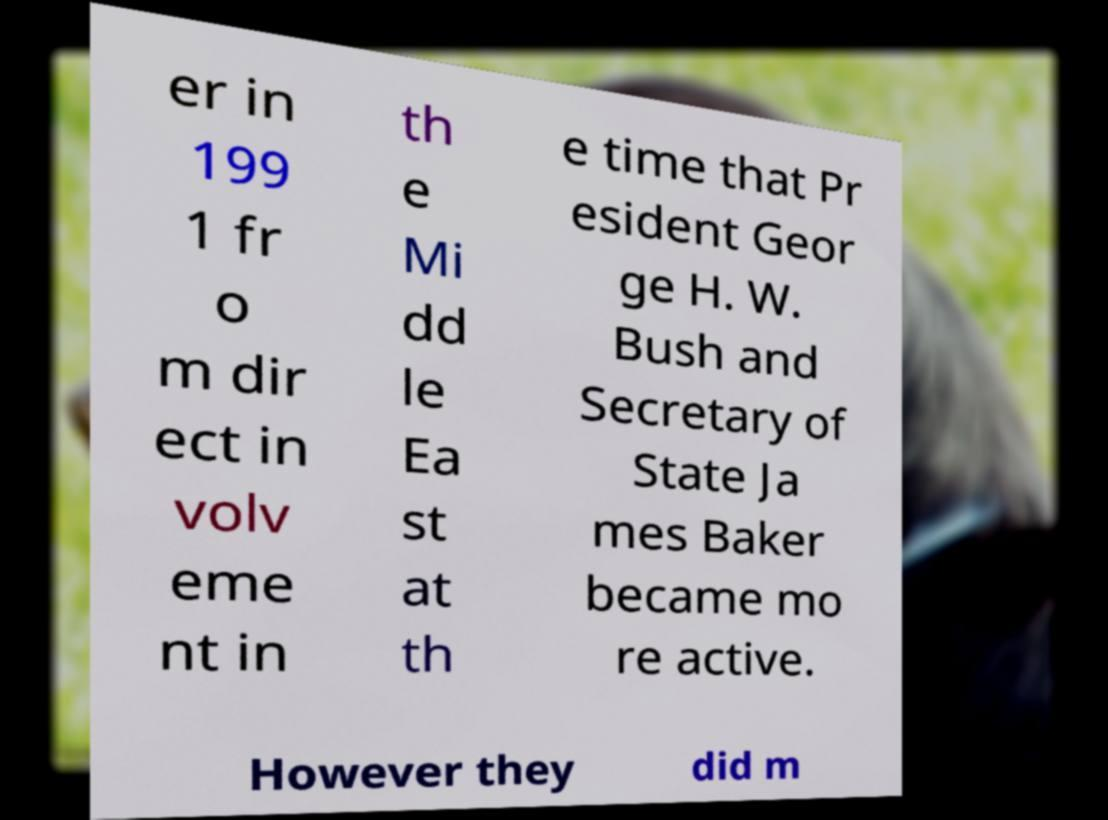For documentation purposes, I need the text within this image transcribed. Could you provide that? er in 199 1 fr o m dir ect in volv eme nt in th e Mi dd le Ea st at th e time that Pr esident Geor ge H. W. Bush and Secretary of State Ja mes Baker became mo re active. However they did m 